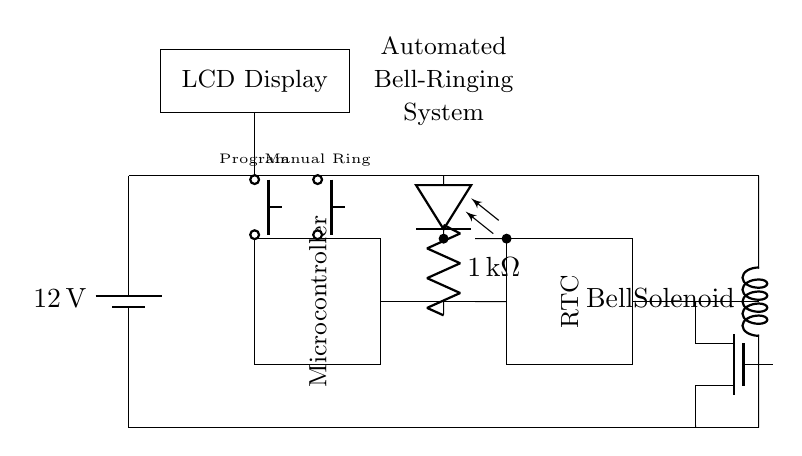What is the voltage in this circuit? The voltage in the circuit is provided by the battery, which is labeled as 12V at the top left corner of the diagram.
Answer: 12V What type of component is used to control the bell? The bell solenoid is the component indicated in the diagram as a direct interface for ringing the bell, located at the bottom right section.
Answer: Bell solenoid How is the manual ringing of the bell activated? The manual ringing is initiated by pressing the push button labeled "Manual Ring," located in the middle left section of the circuit, which connects to the microcontroller.
Answer: Push button Which component connects the microcontroller to the real-time clock? The connection between the microcontroller and the real-time clock is made through a direct wire indicated in the diagram, which runs horizontally between the two components.
Answer: Wire What component provides isolation between the microcontroller and the bell circuit? The optocoupler serves as the isolation device, reducing the risk of high voltage affecting the microcontroller, as indicated in the top middle section of the diagram.
Answer: Optocoupler How many buttons are present for user interaction? There are two buttons visible in the circuit diagram, labeled as "Program" and "Manual Ring," both positioned in the upper left quadrant of the diagram.
Answer: Two buttons What is the purpose of the real-time clock in this system? The real-time clock (RTC) allows the system to keep accurate time, enabling scheduled ringing of the bell at predefined intervals, as inferred from its functional relationship with the microcontroller.
Answer: Scheduled ringing 